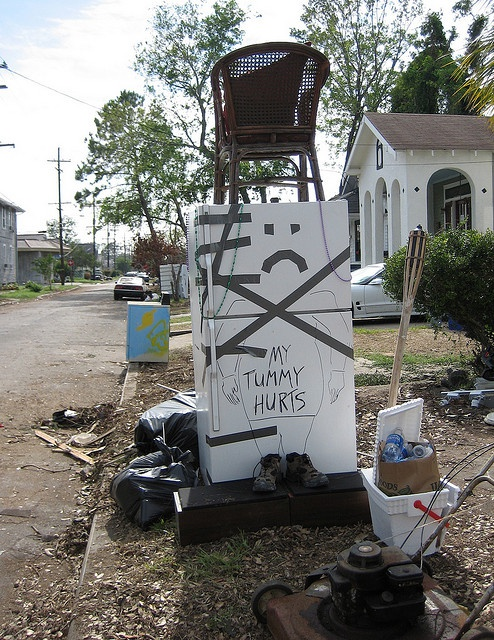Describe the objects in this image and their specific colors. I can see refrigerator in lightblue, darkgray, gray, black, and lightgray tones, chair in lightblue, black, gray, and white tones, car in lightblue, darkgray, gray, white, and black tones, car in lightblue, black, white, darkgray, and gray tones, and car in lightblue, gray, black, white, and darkgray tones in this image. 